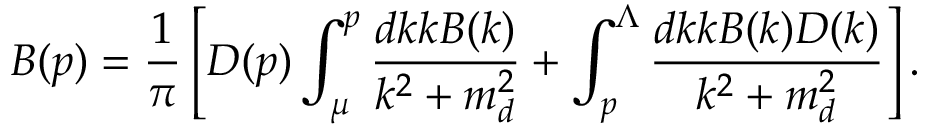<formula> <loc_0><loc_0><loc_500><loc_500>B ( p ) = \frac { 1 } { \pi } \left [ D ( p ) \int _ { \mu } ^ { p } \frac { d k k B ( k ) } { k ^ { 2 } + m _ { d } ^ { 2 } } + \int _ { p } ^ { \Lambda } \frac { d k k B ( k ) D ( k ) } { k ^ { 2 } + m _ { d } ^ { 2 } } \right ] .</formula> 